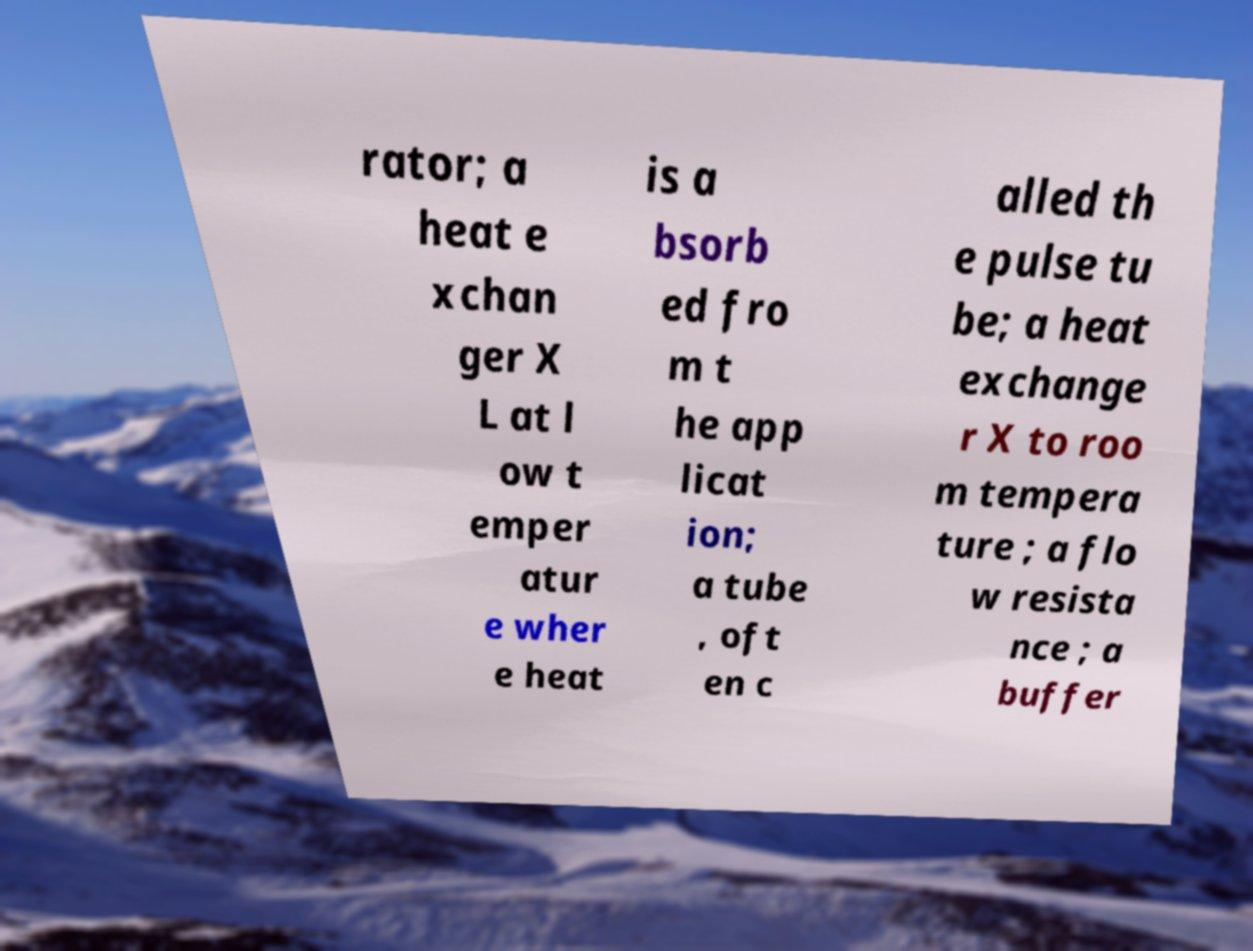What messages or text are displayed in this image? I need them in a readable, typed format. rator; a heat e xchan ger X L at l ow t emper atur e wher e heat is a bsorb ed fro m t he app licat ion; a tube , oft en c alled th e pulse tu be; a heat exchange r X to roo m tempera ture ; a flo w resista nce ; a buffer 